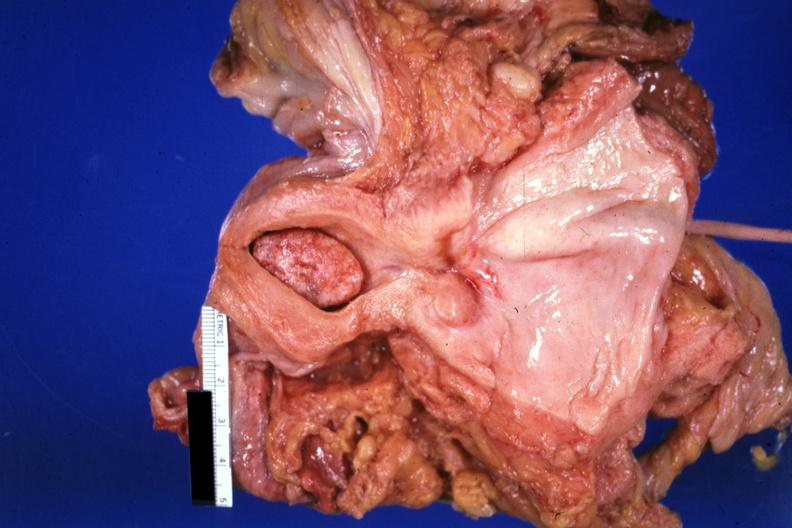s exact cause present?
Answer the question using a single word or phrase. No 